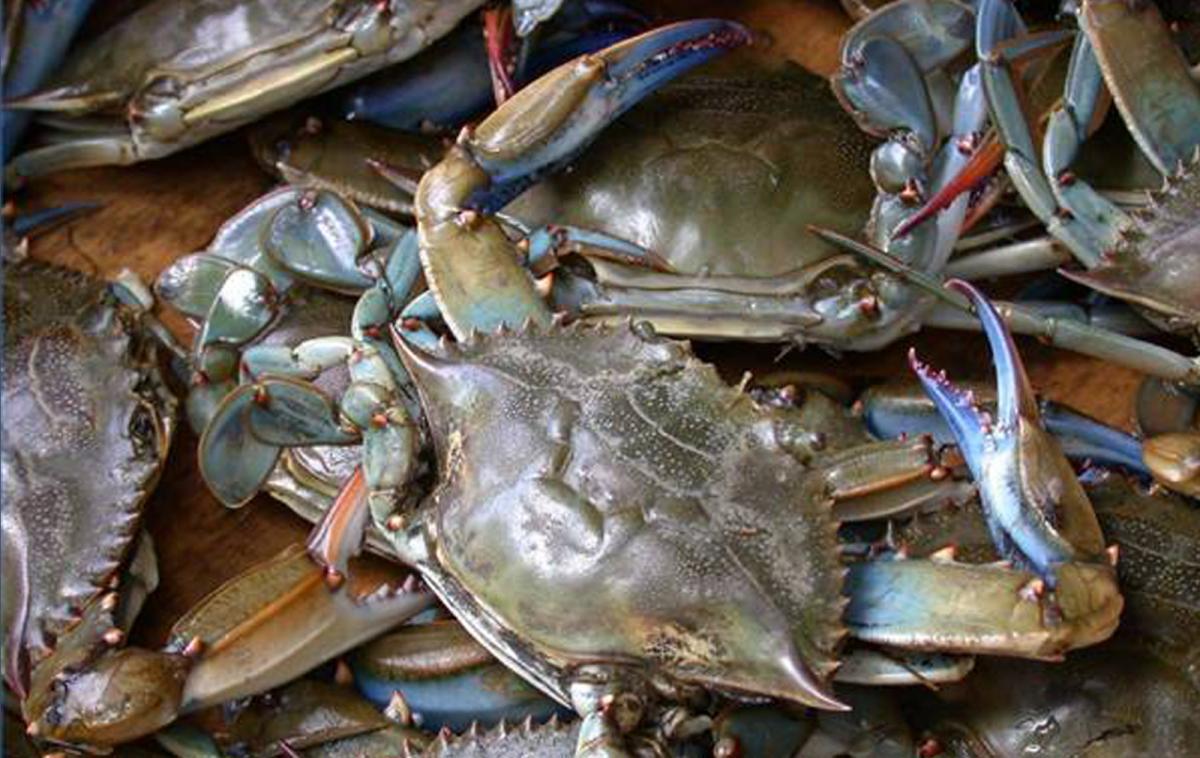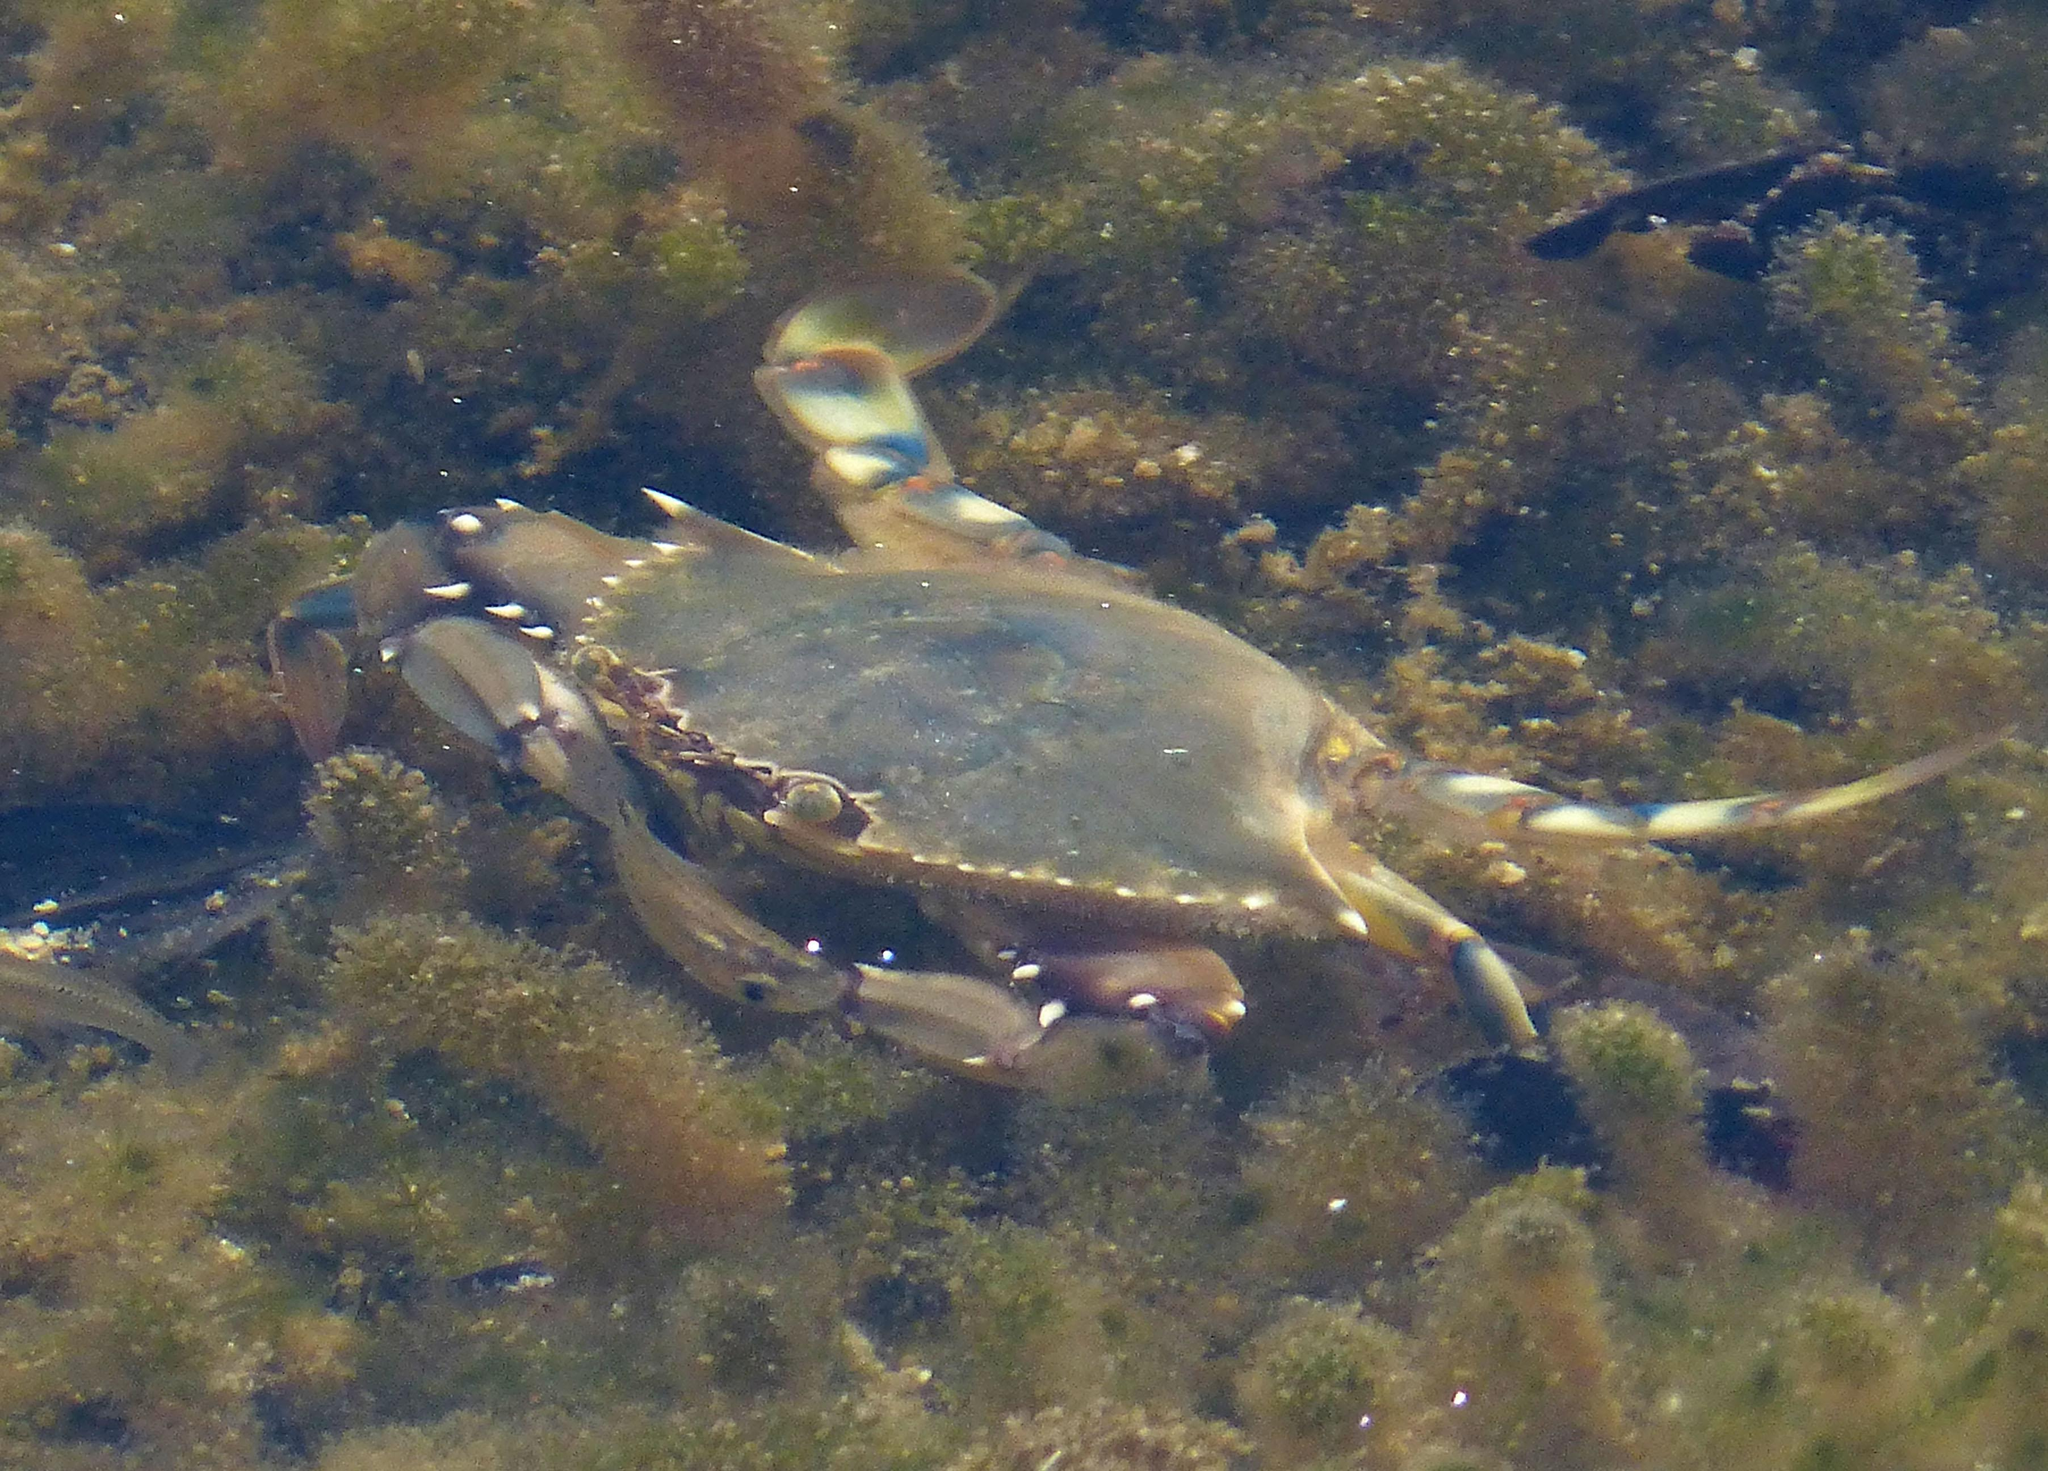The first image is the image on the left, the second image is the image on the right. For the images shown, is this caption "Atleast one picture of a crab in water." true? Answer yes or no. Yes. The first image is the image on the left, the second image is the image on the right. Evaluate the accuracy of this statement regarding the images: "The left image shows a mass of crabs with their purplish-grayish shells facing up, and the right image shows one crab toward the bottom of the seabed facing forward at an angle.". Is it true? Answer yes or no. Yes. 